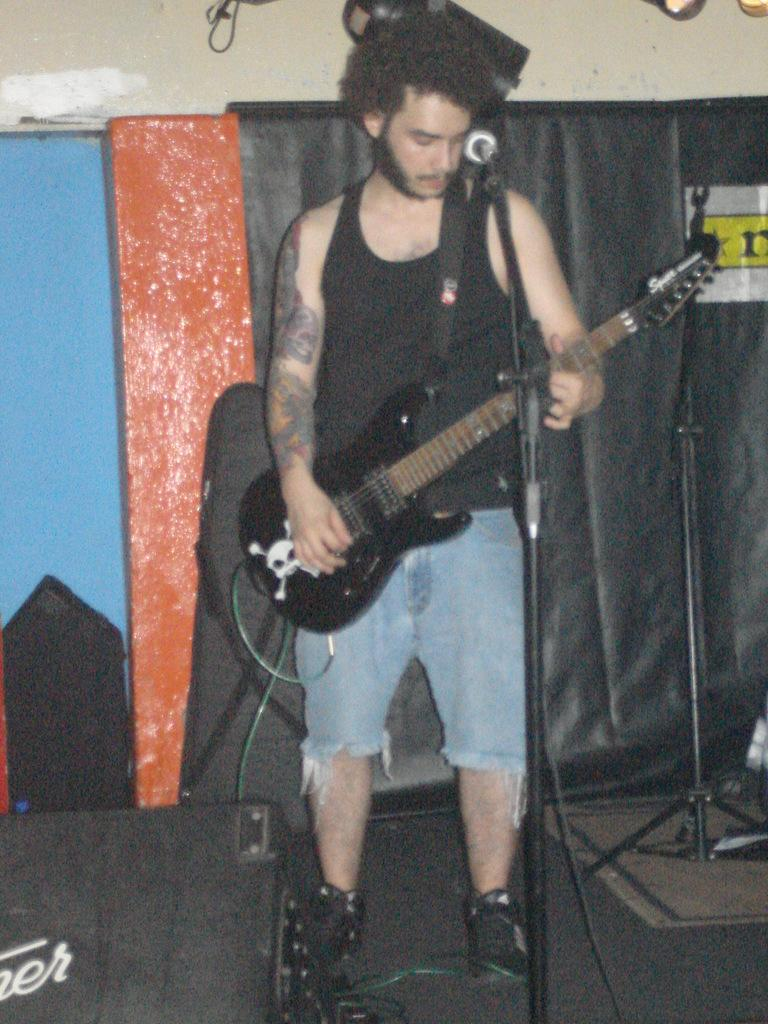What is the main subject of the image? There is a man in the image. What is the man wearing? The man is wearing a black vest. What object is the man holding? The man is holding a guitar. What color is the carpet in the image? There is a black color carpet in the image. What can be seen in the background of the image? There is a cream wall in the background of the image. How does the man's guitar affect the friction between the carpet and the wall in the image? The guitar does not affect the friction between the carpet and the wall in the image, as it is not interacting with either surface. 